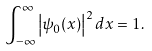Convert formula to latex. <formula><loc_0><loc_0><loc_500><loc_500>\int _ { - \infty } ^ { \infty } \left | \psi _ { 0 } ( x ) \right | ^ { 2 } d x = 1 .</formula> 